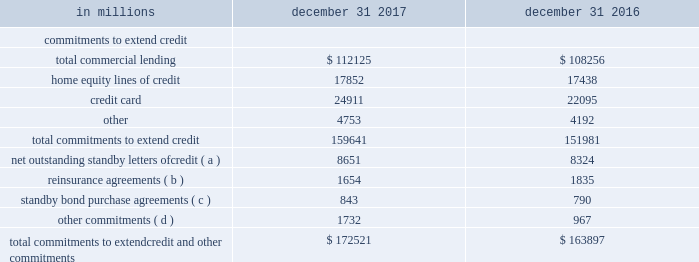152 the pnc financial services group , inc .
2013 form 10-k in addition to the proceedings or other matters described above , pnc and persons to whom we may have indemnification obligations , in the normal course of business , are subject to various other pending and threatened legal proceedings in which claims for monetary damages and other relief are asserted .
We do not anticipate , at the present time , that the ultimate aggregate liability , if any , arising out of such other legal proceedings will have a material adverse effect on our financial position .
However , we cannot now determine whether or not any claims asserted against us or others to whom we may have indemnification obligations , whether in the proceedings or other matters described above or otherwise , will have a material adverse effect on our results of operations in any future reporting period , which will depend on , among other things , the amount of the loss resulting from the claim and the amount of income otherwise reported for the reporting period .
Note 20 commitments in the normal course of business , we have various commitments outstanding , certain of which are not included on our consolidated balance sheet .
The table presents our outstanding commitments to extend credit along with significant other commitments as of december 31 , 2017 and december 31 , 2016 , respectively .
Table 98 : commitments to extend credit and other commitments in millions december 31 december 31 .
Commitments to extend credit , or net unfunded loan commitments , represent arrangements to lend funds or provide liquidity subject to specified contractual conditions .
These commitments generally have fixed expiration dates , may require payment of a fee , and contain termination clauses in the event the customer 2019s credit quality deteriorates .
Net outstanding standby letters of credit we issue standby letters of credit and share in the risk of standby letters of credit issued by other financial institutions , in each case to support obligations of our customers to third parties , such as insurance requirements and the facilitation of transactions involving capital markets product execution .
Approximately 91% ( 91 % ) and 94% ( 94 % ) of our net outstanding standby letters of credit were rated as pass as of december 31 , 2017 and december 31 , 2016 , respectively , with the remainder rated as below pass .
An internal credit rating of pass indicates the expected risk of loss is currently low , while a rating of below pass indicates a higher degree of risk .
If the customer fails to meet its financial or performance obligation to the third party under the terms of the contract or there is a need to support a remarketing program , then upon a draw by a beneficiary , subject to the terms of the letter of credit , we would be obligated to make payment to them .
The standby letters of credit outstanding on december 31 , 2017 had terms ranging from less than one year to seven years .
As of december 31 , 2017 , assets of $ 1.3 billion secured certain specifically identified standby letters of credit .
In addition , a portion of the remaining standby letters of credit issued on behalf of specific customers is also secured by collateral or guarantees that secure the customers 2019 other obligations to us .
The carrying amount of the liability for our obligations related to standby letters of credit and participations in standby letters of credit was $ .2 billion at december 31 , 2017 and is included in other liabilities on our consolidated balance sheet. .
What was the change in the total commitments to extend credit from 2016 top 2017? 
Computations: ((159641 - 151981) / 151981)
Answer: 0.0504. 